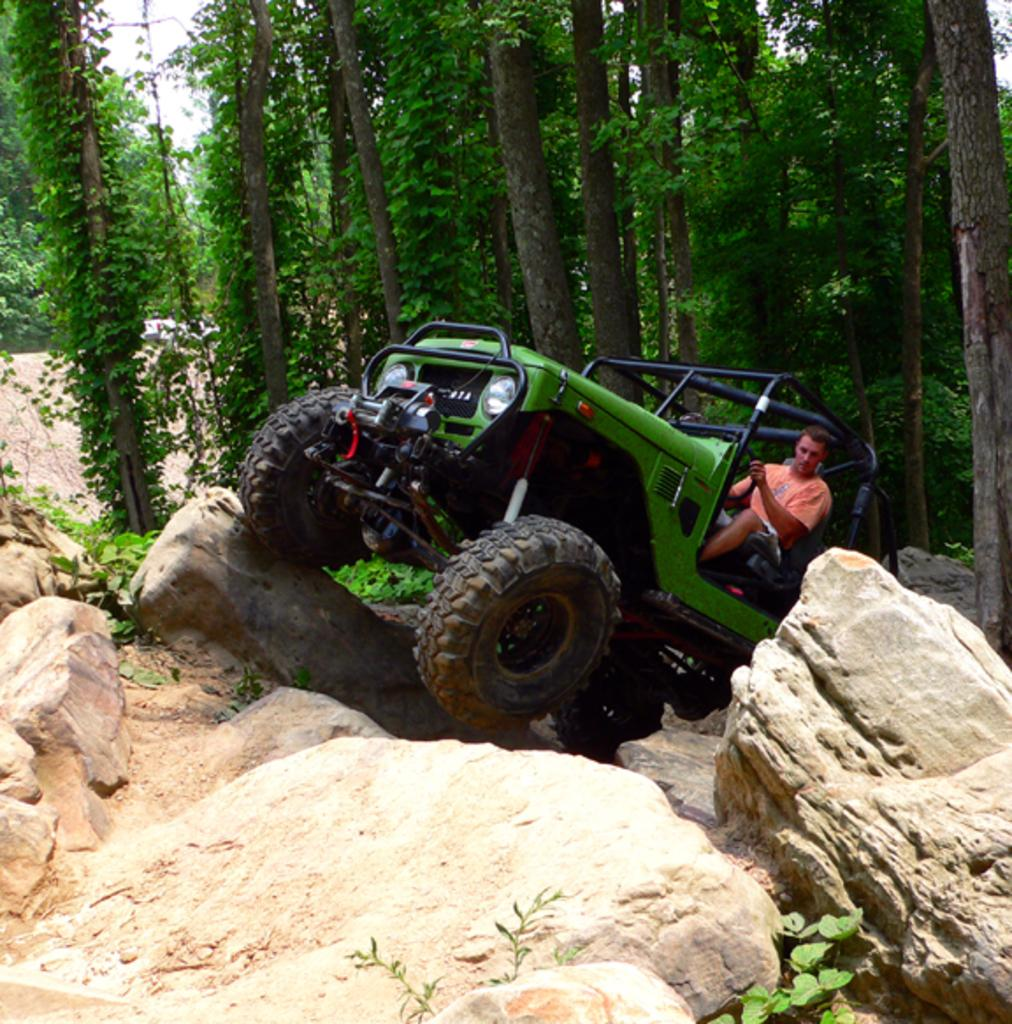What is the man in the image doing? The man is seated in a jeep. What type of terrain can be seen in the image? There are rocks visible in the image. What type of vegetation is present in the image? There are plants and trees in the image. What type of glass is the man drinking from in the image? There is no glass present in the image; the man is seated in a jeep. 